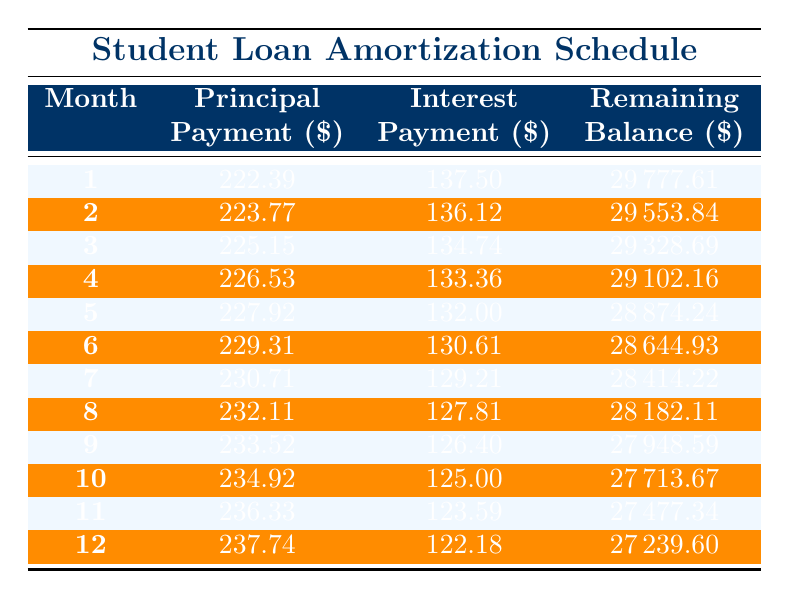What is the principal payment in the first month? Looking at the table, the principal payment for month 1 is listed in the first row under the "Principal Payment" column. It shows 222.39.
Answer: 222.39 How much interest is paid in the 6th month? In the table, you can find the interest payment for month 6, which is shown in the corresponding row for that month. It is 130.61.
Answer: 130.61 What is the remaining balance after the 12th month? The remaining balance after the 12th month is found in the last row of the table under "Remaining Balance." It shows 27239.60.
Answer: 27239.60 What is the average monthly principal payment for the first three months? To find the average, add the principal payments for the first three months: 222.39 + 223.77 + 225.15 = 671.31. Then divide that sum by 3, which gives 671.31 / 3 = 223.77.
Answer: 223.77 Is the interest payment decreasing over the months? Observing the column for interest payments, it is evident that the values are getting smaller with each month, confirming that interest payments are indeed decreasing over time.
Answer: Yes What is the total principal payment made in the first year? The total principal payment for the first year is calculated by summing the principal payments from month 1 to month 12. The total is 222.39 + 223.77 + 225.15 + 226.53 + 227.92 + 229.31 + 230.71 + 232.11 + 233.52 + 234.92 + 236.33 + 237.74 = 2742.01.
Answer: 2742.01 What is the difference between the principal payment in the 1st month and the 12th month? The principal payment in the 1st month is 222.39 and in the 12th month is 237.74. To find the difference, subtract the 1st month payment from the 12th month payment: 237.74 - 222.39 = 15.35.
Answer: 15.35 How much total interest is paid over the first year? To calculate the total interest paid over the first year, sum the interest payments from month 1 to month 12. This gives: 137.50 + 136.12 + 134.74 + 133.36 + 132.00 + 130.61 + 129.21 + 127.81 + 126.40 + 125.00 + 123.59 + 122.18 = 1,614.22.
Answer: 1614.22 Is the monthly payment consistent each month? The monthly payment of 322.39 remains constant as it is the same for every month listed in the table, indicating the payments are consistent.
Answer: Yes 